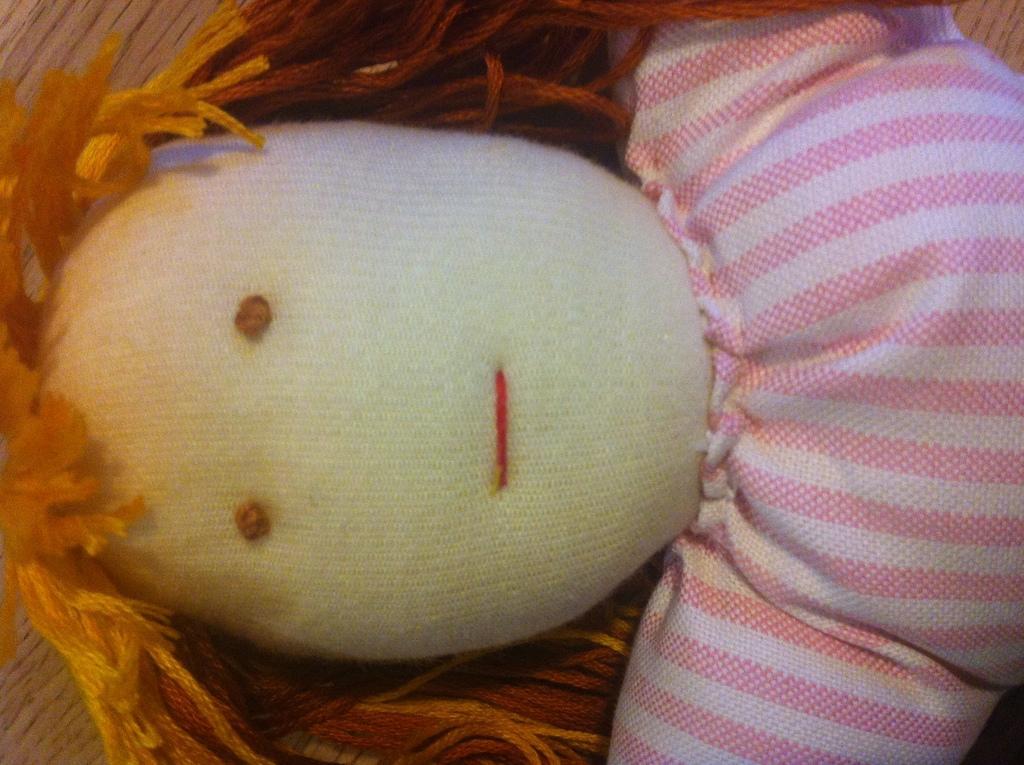In one or two sentences, can you explain what this image depicts? In this picture there is a doll in the center of the image. 